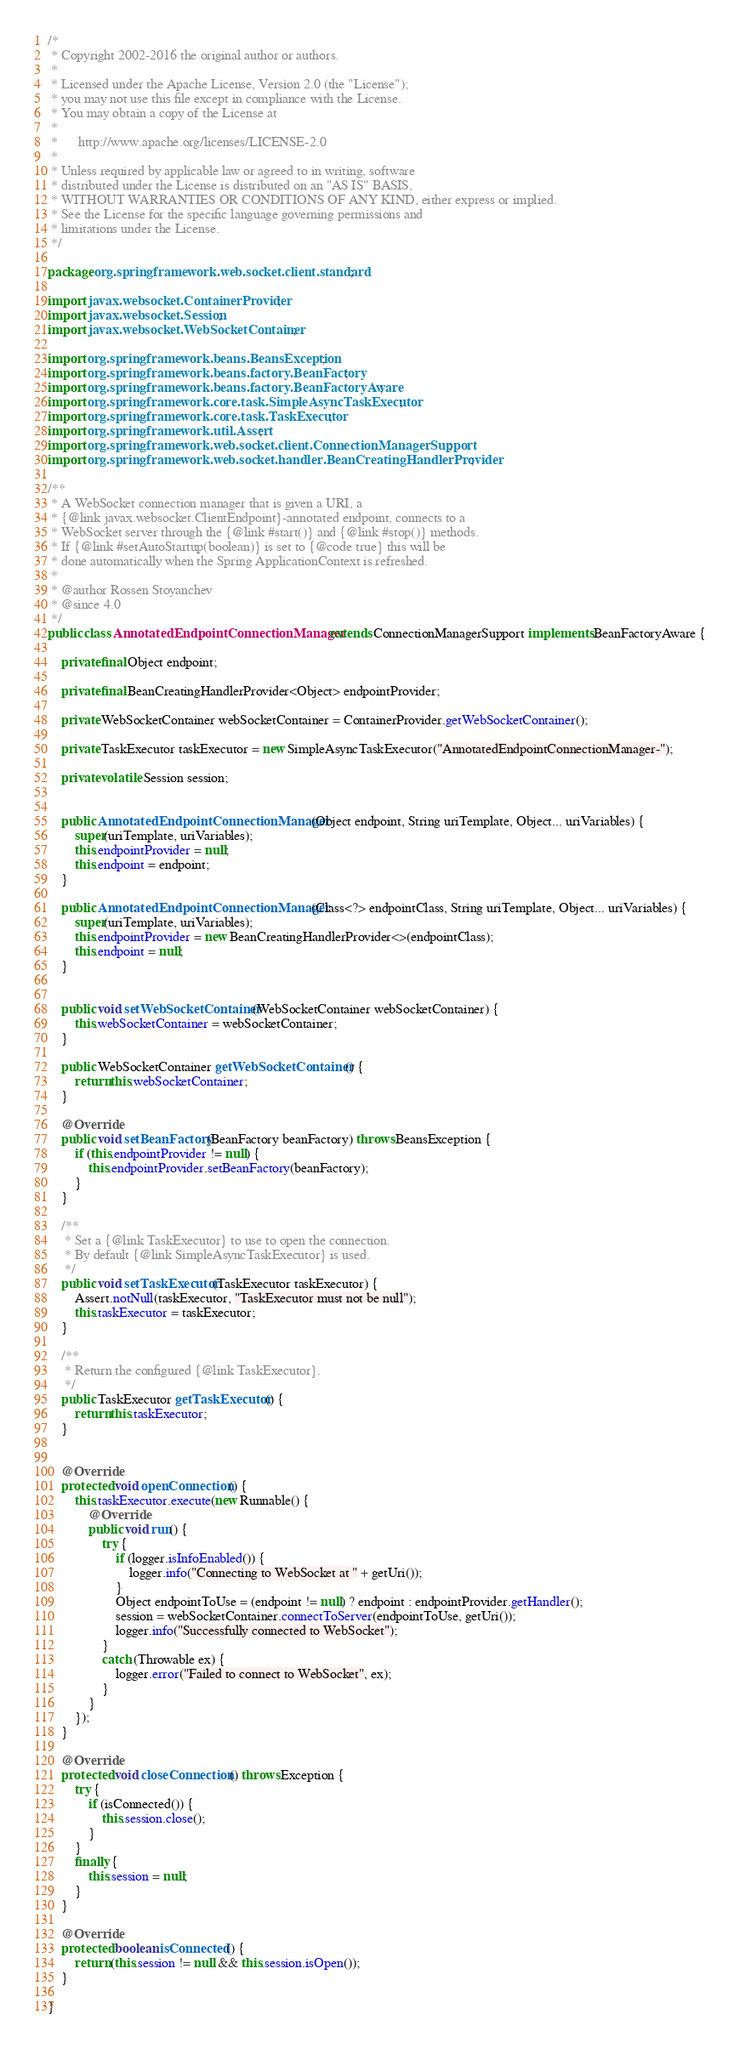Convert code to text. <code><loc_0><loc_0><loc_500><loc_500><_Java_>/*
 * Copyright 2002-2016 the original author or authors.
 *
 * Licensed under the Apache License, Version 2.0 (the "License");
 * you may not use this file except in compliance with the License.
 * You may obtain a copy of the License at
 *
 *      http://www.apache.org/licenses/LICENSE-2.0
 *
 * Unless required by applicable law or agreed to in writing, software
 * distributed under the License is distributed on an "AS IS" BASIS,
 * WITHOUT WARRANTIES OR CONDITIONS OF ANY KIND, either express or implied.
 * See the License for the specific language governing permissions and
 * limitations under the License.
 */

package org.springframework.web.socket.client.standard;

import javax.websocket.ContainerProvider;
import javax.websocket.Session;
import javax.websocket.WebSocketContainer;

import org.springframework.beans.BeansException;
import org.springframework.beans.factory.BeanFactory;
import org.springframework.beans.factory.BeanFactoryAware;
import org.springframework.core.task.SimpleAsyncTaskExecutor;
import org.springframework.core.task.TaskExecutor;
import org.springframework.util.Assert;
import org.springframework.web.socket.client.ConnectionManagerSupport;
import org.springframework.web.socket.handler.BeanCreatingHandlerProvider;

/**
 * A WebSocket connection manager that is given a URI, a
 * {@link javax.websocket.ClientEndpoint}-annotated endpoint, connects to a
 * WebSocket server through the {@link #start()} and {@link #stop()} methods.
 * If {@link #setAutoStartup(boolean)} is set to {@code true} this will be
 * done automatically when the Spring ApplicationContext is refreshed.
 *
 * @author Rossen Stoyanchev
 * @since 4.0
 */
public class AnnotatedEndpointConnectionManager extends ConnectionManagerSupport implements BeanFactoryAware {

	private final Object endpoint;

	private final BeanCreatingHandlerProvider<Object> endpointProvider;

	private WebSocketContainer webSocketContainer = ContainerProvider.getWebSocketContainer();

	private TaskExecutor taskExecutor = new SimpleAsyncTaskExecutor("AnnotatedEndpointConnectionManager-");

	private volatile Session session;


	public AnnotatedEndpointConnectionManager(Object endpoint, String uriTemplate, Object... uriVariables) {
		super(uriTemplate, uriVariables);
		this.endpointProvider = null;
		this.endpoint = endpoint;
	}

	public AnnotatedEndpointConnectionManager(Class<?> endpointClass, String uriTemplate, Object... uriVariables) {
		super(uriTemplate, uriVariables);
		this.endpointProvider = new BeanCreatingHandlerProvider<>(endpointClass);
		this.endpoint = null;
	}


	public void setWebSocketContainer(WebSocketContainer webSocketContainer) {
		this.webSocketContainer = webSocketContainer;
	}

	public WebSocketContainer getWebSocketContainer() {
		return this.webSocketContainer;
	}

	@Override
	public void setBeanFactory(BeanFactory beanFactory) throws BeansException {
		if (this.endpointProvider != null) {
			this.endpointProvider.setBeanFactory(beanFactory);
		}
	}

	/**
	 * Set a {@link TaskExecutor} to use to open the connection.
	 * By default {@link SimpleAsyncTaskExecutor} is used.
	 */
	public void setTaskExecutor(TaskExecutor taskExecutor) {
		Assert.notNull(taskExecutor, "TaskExecutor must not be null");
		this.taskExecutor = taskExecutor;
	}

	/**
	 * Return the configured {@link TaskExecutor}.
	 */
	public TaskExecutor getTaskExecutor() {
		return this.taskExecutor;
	}


	@Override
	protected void openConnection() {
		this.taskExecutor.execute(new Runnable() {
			@Override
			public void run() {
				try {
					if (logger.isInfoEnabled()) {
						logger.info("Connecting to WebSocket at " + getUri());
					}
					Object endpointToUse = (endpoint != null) ? endpoint : endpointProvider.getHandler();
					session = webSocketContainer.connectToServer(endpointToUse, getUri());
					logger.info("Successfully connected to WebSocket");
				}
				catch (Throwable ex) {
					logger.error("Failed to connect to WebSocket", ex);
				}
			}
		});
	}

	@Override
	protected void closeConnection() throws Exception {
		try {
			if (isConnected()) {
				this.session.close();
			}
		}
		finally {
			this.session = null;
		}
	}

	@Override
	protected boolean isConnected() {
		return (this.session != null && this.session.isOpen());
	}

}
</code> 